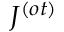Convert formula to latex. <formula><loc_0><loc_0><loc_500><loc_500>J ^ { ( o t ) }</formula> 